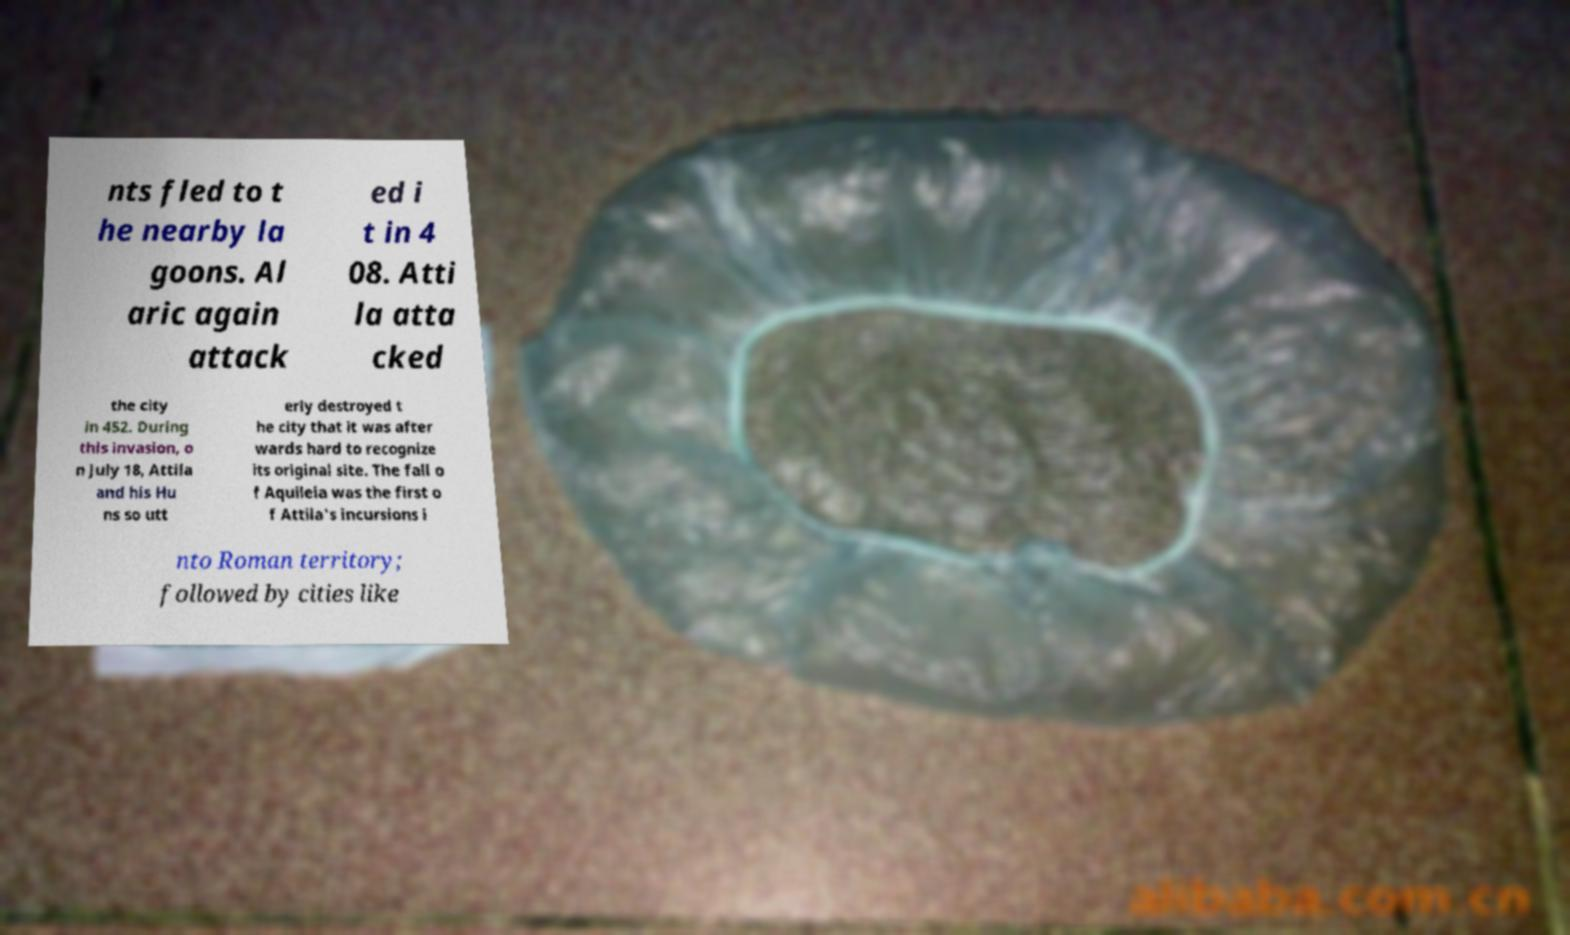Please read and relay the text visible in this image. What does it say? nts fled to t he nearby la goons. Al aric again attack ed i t in 4 08. Atti la atta cked the city in 452. During this invasion, o n July 18, Attila and his Hu ns so utt erly destroyed t he city that it was after wards hard to recognize its original site. The fall o f Aquileia was the first o f Attila's incursions i nto Roman territory; followed by cities like 